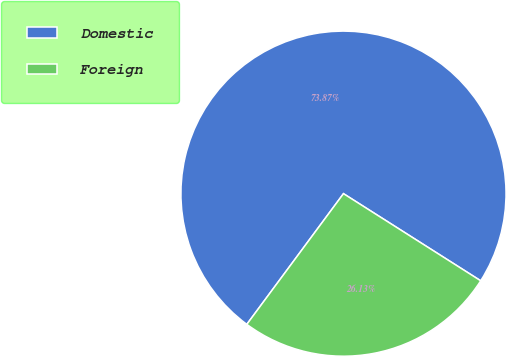Convert chart. <chart><loc_0><loc_0><loc_500><loc_500><pie_chart><fcel>Domestic<fcel>Foreign<nl><fcel>73.87%<fcel>26.13%<nl></chart> 